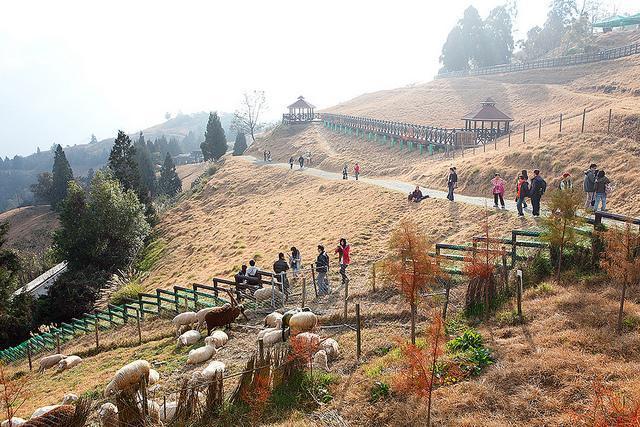How many gazebos do you see?
Give a very brief answer. 2. 